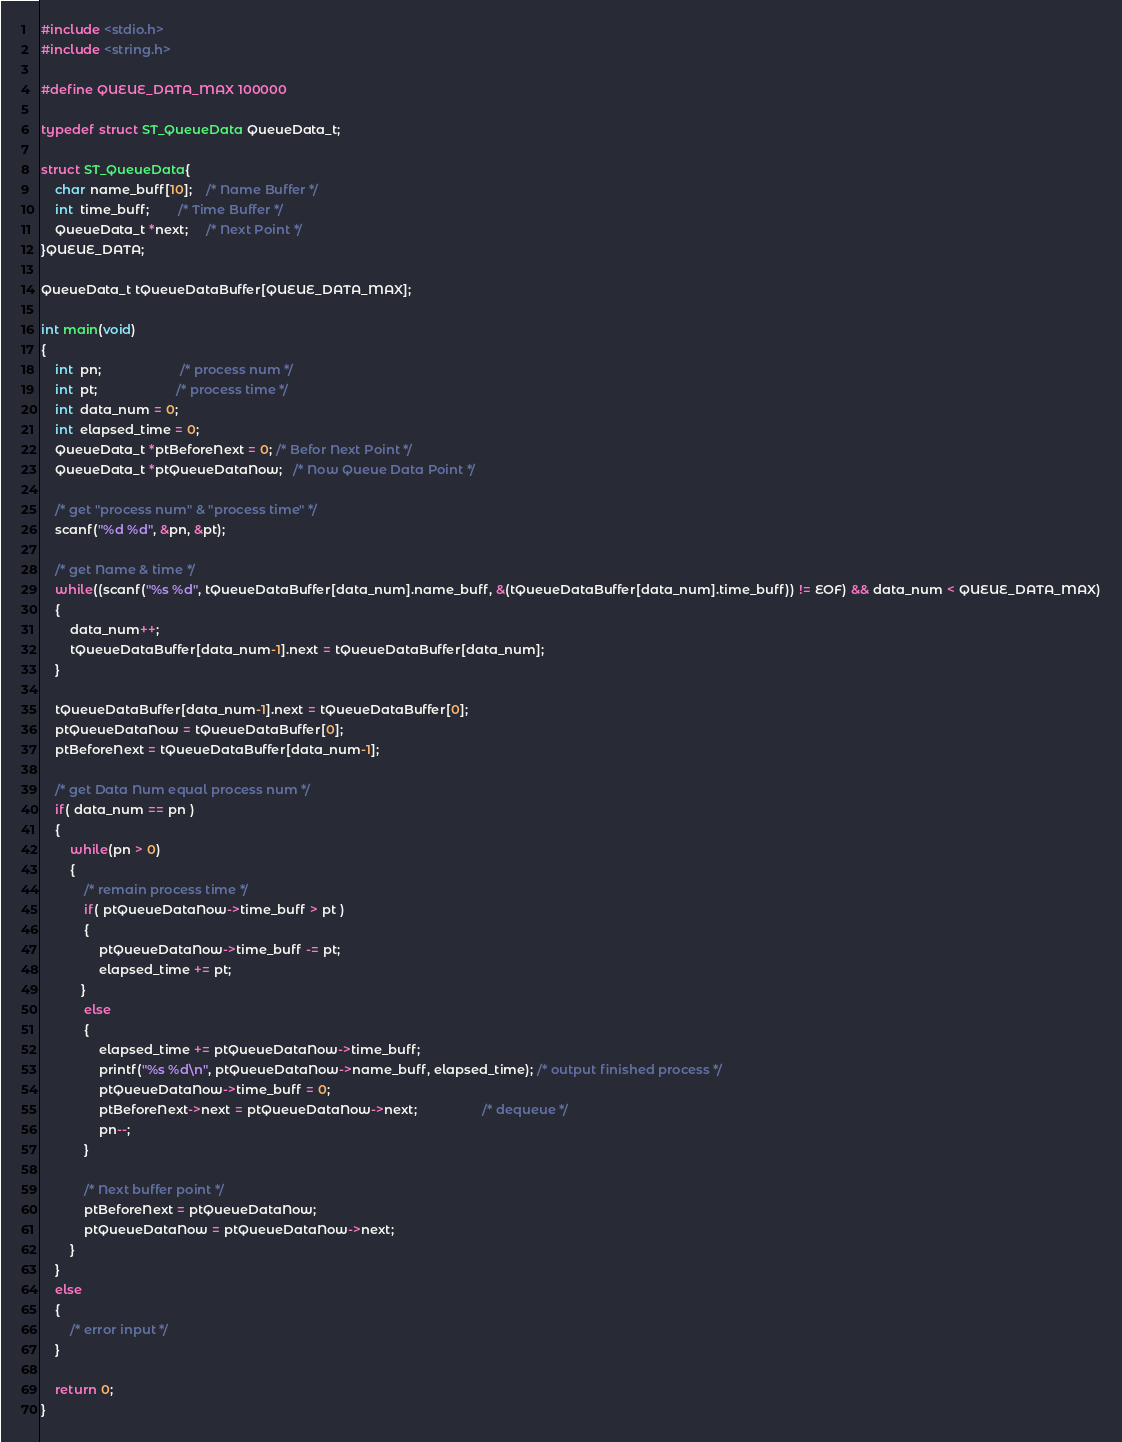<code> <loc_0><loc_0><loc_500><loc_500><_C_>#include <stdio.h>
#include <string.h>

#define QUEUE_DATA_MAX 100000

typedef struct ST_QueueData QueueData_t;

struct ST_QueueData{
    char name_buff[10];    /* Name Buffer */
    int  time_buff;        /* Time Buffer */
	QueueData_t *next;     /* Next Point */
}QUEUE_DATA;

QueueData_t tQueueDataBuffer[QUEUE_DATA_MAX];

int main(void)
{
    int  pn;                      /* process num */
    int  pt;                      /* process time */
    int  data_num = 0;
    int  elapsed_time = 0;
    QueueData_t *ptBeforeNext = 0; /* Befor Next Point */
    QueueData_t *ptQueueDataNow;   /* Now Queue Data Point */
    
    /* get "process num" & "process time" */
    scanf("%d %d", &pn, &pt);
     
    /* get Name & time */
    while((scanf("%s %d", tQueueDataBuffer[data_num].name_buff, &(tQueueDataBuffer[data_num].time_buff)) != EOF) && data_num < QUEUE_DATA_MAX)
    {
        data_num++;
    	tQueueDataBuffer[data_num-1].next = tQueueDataBuffer[data_num];
    }
    
	tQueueDataBuffer[data_num-1].next = tQueueDataBuffer[0];
	ptQueueDataNow = tQueueDataBuffer[0];
	ptBeforeNext = tQueueDataBuffer[data_num-1];
	
    /* get Data Num equal process num */
    if( data_num == pn )
    {
        while(pn > 0)
        {
            /* remain process time */
            if( ptQueueDataNow->time_buff > pt )
            {
                ptQueueDataNow->time_buff -= pt;
                elapsed_time += pt;
           }
            else
            {
                elapsed_time += ptQueueDataNow->time_buff;
                printf("%s %d\n", ptQueueDataNow->name_buff, elapsed_time); /* output finished process */
                ptQueueDataNow->time_buff = 0;
                ptBeforeNext->next = ptQueueDataNow->next;                  /* dequeue */
                pn--;
            }
             
            /* Next buffer point */
            ptBeforeNext = ptQueueDataNow;
            ptQueueDataNow = ptQueueDataNow->next;
        }
    }
    else
    {
        /* error input */
    }
     
    return 0;
}</code> 